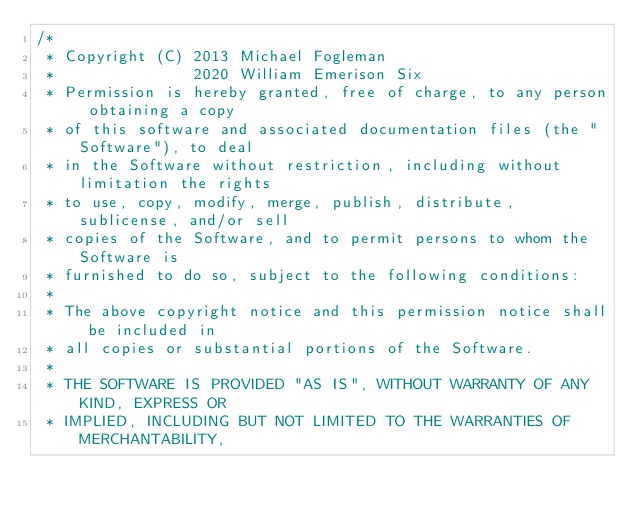<code> <loc_0><loc_0><loc_500><loc_500><_C_>/*
 * Copyright (C) 2013 Michael Fogleman
 *               2020 William Emerison Six
 * Permission is hereby granted, free of charge, to any person obtaining a copy
 * of this software and associated documentation files (the "Software"), to deal
 * in the Software without restriction, including without limitation the rights
 * to use, copy, modify, merge, publish, distribute, sublicense, and/or sell
 * copies of the Software, and to permit persons to whom the Software is
 * furnished to do so, subject to the following conditions:
 *
 * The above copyright notice and this permission notice shall be included in
 * all copies or substantial portions of the Software.
 *
 * THE SOFTWARE IS PROVIDED "AS IS", WITHOUT WARRANTY OF ANY KIND, EXPRESS OR
 * IMPLIED, INCLUDING BUT NOT LIMITED TO THE WARRANTIES OF MERCHANTABILITY,</code> 